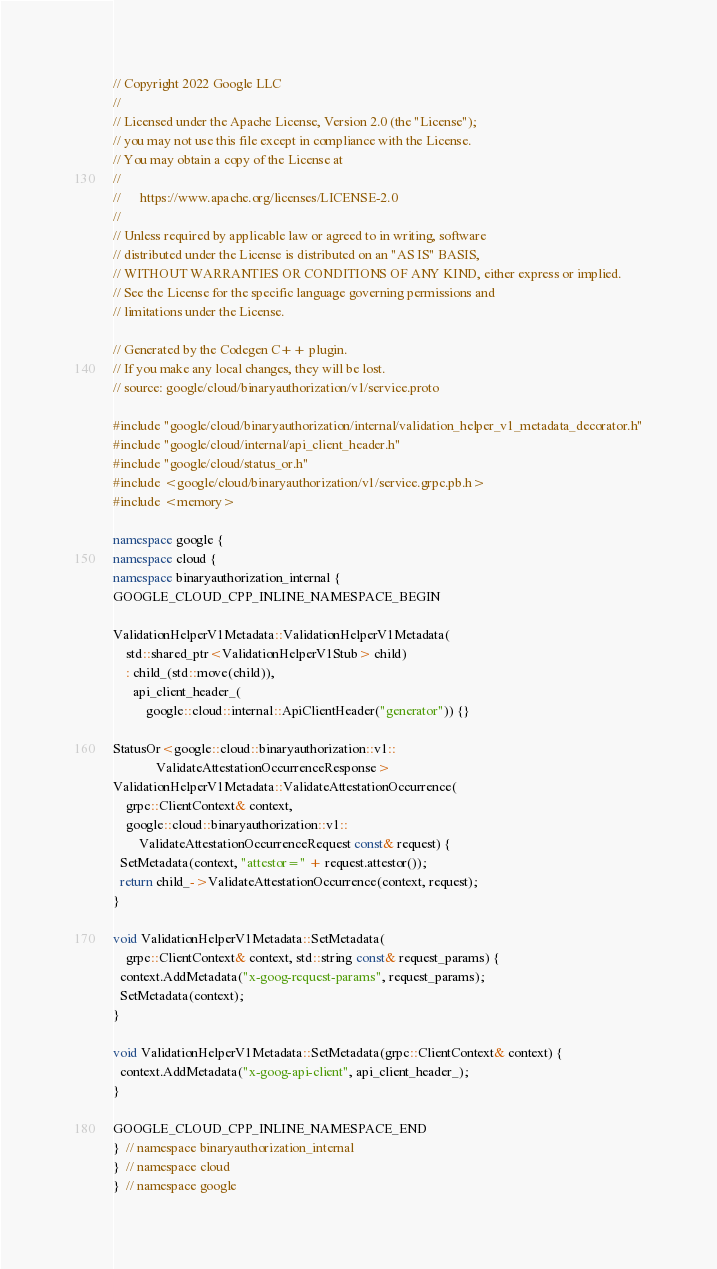Convert code to text. <code><loc_0><loc_0><loc_500><loc_500><_C++_>// Copyright 2022 Google LLC
//
// Licensed under the Apache License, Version 2.0 (the "License");
// you may not use this file except in compliance with the License.
// You may obtain a copy of the License at
//
//      https://www.apache.org/licenses/LICENSE-2.0
//
// Unless required by applicable law or agreed to in writing, software
// distributed under the License is distributed on an "AS IS" BASIS,
// WITHOUT WARRANTIES OR CONDITIONS OF ANY KIND, either express or implied.
// See the License for the specific language governing permissions and
// limitations under the License.

// Generated by the Codegen C++ plugin.
// If you make any local changes, they will be lost.
// source: google/cloud/binaryauthorization/v1/service.proto

#include "google/cloud/binaryauthorization/internal/validation_helper_v1_metadata_decorator.h"
#include "google/cloud/internal/api_client_header.h"
#include "google/cloud/status_or.h"
#include <google/cloud/binaryauthorization/v1/service.grpc.pb.h>
#include <memory>

namespace google {
namespace cloud {
namespace binaryauthorization_internal {
GOOGLE_CLOUD_CPP_INLINE_NAMESPACE_BEGIN

ValidationHelperV1Metadata::ValidationHelperV1Metadata(
    std::shared_ptr<ValidationHelperV1Stub> child)
    : child_(std::move(child)),
      api_client_header_(
          google::cloud::internal::ApiClientHeader("generator")) {}

StatusOr<google::cloud::binaryauthorization::v1::
             ValidateAttestationOccurrenceResponse>
ValidationHelperV1Metadata::ValidateAttestationOccurrence(
    grpc::ClientContext& context,
    google::cloud::binaryauthorization::v1::
        ValidateAttestationOccurrenceRequest const& request) {
  SetMetadata(context, "attestor=" + request.attestor());
  return child_->ValidateAttestationOccurrence(context, request);
}

void ValidationHelperV1Metadata::SetMetadata(
    grpc::ClientContext& context, std::string const& request_params) {
  context.AddMetadata("x-goog-request-params", request_params);
  SetMetadata(context);
}

void ValidationHelperV1Metadata::SetMetadata(grpc::ClientContext& context) {
  context.AddMetadata("x-goog-api-client", api_client_header_);
}

GOOGLE_CLOUD_CPP_INLINE_NAMESPACE_END
}  // namespace binaryauthorization_internal
}  // namespace cloud
}  // namespace google
</code> 